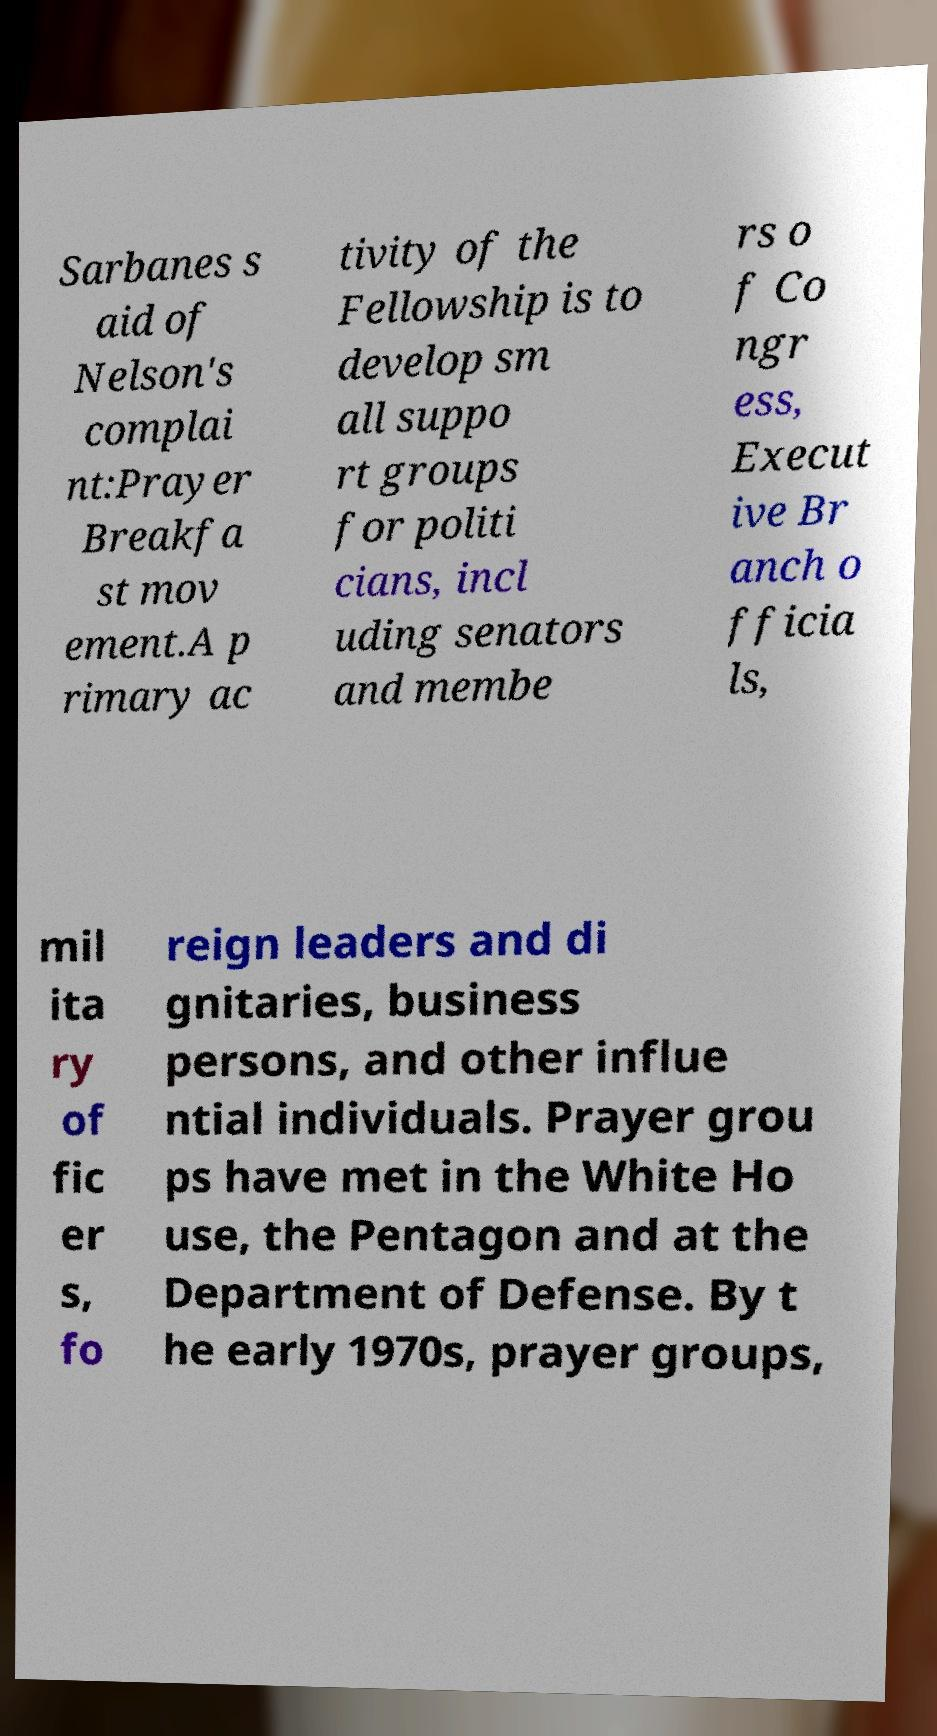There's text embedded in this image that I need extracted. Can you transcribe it verbatim? Sarbanes s aid of Nelson's complai nt:Prayer Breakfa st mov ement.A p rimary ac tivity of the Fellowship is to develop sm all suppo rt groups for politi cians, incl uding senators and membe rs o f Co ngr ess, Execut ive Br anch o fficia ls, mil ita ry of fic er s, fo reign leaders and di gnitaries, business persons, and other influe ntial individuals. Prayer grou ps have met in the White Ho use, the Pentagon and at the Department of Defense. By t he early 1970s, prayer groups, 